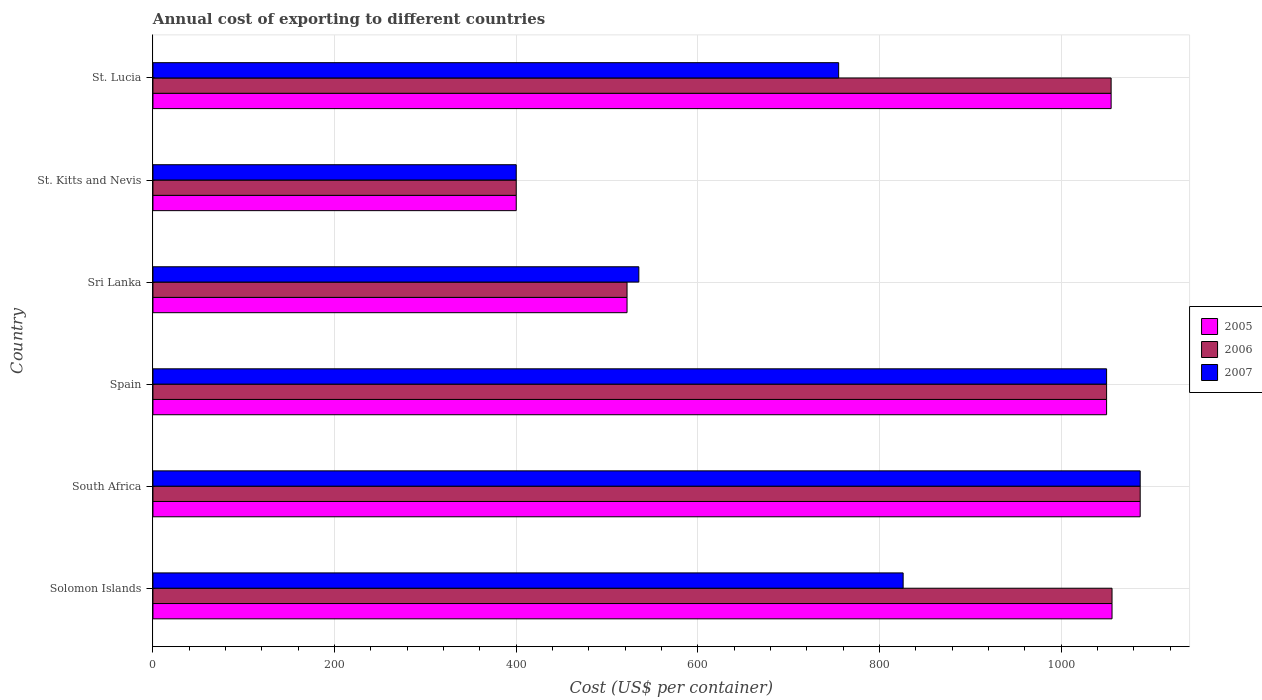How many groups of bars are there?
Your answer should be very brief. 6. Are the number of bars per tick equal to the number of legend labels?
Give a very brief answer. Yes. How many bars are there on the 4th tick from the top?
Your answer should be compact. 3. What is the label of the 5th group of bars from the top?
Make the answer very short. South Africa. What is the total annual cost of exporting in 2005 in South Africa?
Your answer should be very brief. 1087. Across all countries, what is the maximum total annual cost of exporting in 2005?
Offer a terse response. 1087. Across all countries, what is the minimum total annual cost of exporting in 2005?
Provide a short and direct response. 400. In which country was the total annual cost of exporting in 2006 maximum?
Provide a short and direct response. South Africa. In which country was the total annual cost of exporting in 2005 minimum?
Offer a terse response. St. Kitts and Nevis. What is the total total annual cost of exporting in 2005 in the graph?
Ensure brevity in your answer.  5170. What is the difference between the total annual cost of exporting in 2005 in Spain and that in Sri Lanka?
Ensure brevity in your answer.  528. What is the difference between the total annual cost of exporting in 2006 in Sri Lanka and the total annual cost of exporting in 2007 in Spain?
Give a very brief answer. -528. What is the average total annual cost of exporting in 2006 per country?
Ensure brevity in your answer.  861.67. What is the ratio of the total annual cost of exporting in 2006 in South Africa to that in St. Lucia?
Your answer should be compact. 1.03. What is the difference between the highest and the lowest total annual cost of exporting in 2006?
Provide a short and direct response. 687. How many bars are there?
Provide a short and direct response. 18. What is the difference between two consecutive major ticks on the X-axis?
Ensure brevity in your answer.  200. Are the values on the major ticks of X-axis written in scientific E-notation?
Your response must be concise. No. Does the graph contain any zero values?
Offer a very short reply. No. Does the graph contain grids?
Ensure brevity in your answer.  Yes. Where does the legend appear in the graph?
Make the answer very short. Center right. How many legend labels are there?
Provide a succinct answer. 3. What is the title of the graph?
Provide a short and direct response. Annual cost of exporting to different countries. Does "1965" appear as one of the legend labels in the graph?
Provide a short and direct response. No. What is the label or title of the X-axis?
Make the answer very short. Cost (US$ per container). What is the label or title of the Y-axis?
Keep it short and to the point. Country. What is the Cost (US$ per container) of 2005 in Solomon Islands?
Provide a short and direct response. 1056. What is the Cost (US$ per container) of 2006 in Solomon Islands?
Ensure brevity in your answer.  1056. What is the Cost (US$ per container) of 2007 in Solomon Islands?
Keep it short and to the point. 826. What is the Cost (US$ per container) in 2005 in South Africa?
Ensure brevity in your answer.  1087. What is the Cost (US$ per container) in 2006 in South Africa?
Provide a succinct answer. 1087. What is the Cost (US$ per container) of 2007 in South Africa?
Make the answer very short. 1087. What is the Cost (US$ per container) in 2005 in Spain?
Make the answer very short. 1050. What is the Cost (US$ per container) in 2006 in Spain?
Ensure brevity in your answer.  1050. What is the Cost (US$ per container) of 2007 in Spain?
Keep it short and to the point. 1050. What is the Cost (US$ per container) of 2005 in Sri Lanka?
Give a very brief answer. 522. What is the Cost (US$ per container) of 2006 in Sri Lanka?
Keep it short and to the point. 522. What is the Cost (US$ per container) of 2007 in Sri Lanka?
Your answer should be very brief. 535. What is the Cost (US$ per container) in 2006 in St. Kitts and Nevis?
Give a very brief answer. 400. What is the Cost (US$ per container) of 2005 in St. Lucia?
Provide a short and direct response. 1055. What is the Cost (US$ per container) of 2006 in St. Lucia?
Your answer should be very brief. 1055. What is the Cost (US$ per container) in 2007 in St. Lucia?
Offer a terse response. 755. Across all countries, what is the maximum Cost (US$ per container) in 2005?
Offer a terse response. 1087. Across all countries, what is the maximum Cost (US$ per container) in 2006?
Offer a terse response. 1087. Across all countries, what is the maximum Cost (US$ per container) of 2007?
Keep it short and to the point. 1087. Across all countries, what is the minimum Cost (US$ per container) in 2007?
Your response must be concise. 400. What is the total Cost (US$ per container) of 2005 in the graph?
Provide a short and direct response. 5170. What is the total Cost (US$ per container) in 2006 in the graph?
Make the answer very short. 5170. What is the total Cost (US$ per container) of 2007 in the graph?
Ensure brevity in your answer.  4653. What is the difference between the Cost (US$ per container) in 2005 in Solomon Islands and that in South Africa?
Give a very brief answer. -31. What is the difference between the Cost (US$ per container) of 2006 in Solomon Islands and that in South Africa?
Provide a succinct answer. -31. What is the difference between the Cost (US$ per container) in 2007 in Solomon Islands and that in South Africa?
Offer a very short reply. -261. What is the difference between the Cost (US$ per container) in 2005 in Solomon Islands and that in Spain?
Your answer should be compact. 6. What is the difference between the Cost (US$ per container) of 2006 in Solomon Islands and that in Spain?
Give a very brief answer. 6. What is the difference between the Cost (US$ per container) in 2007 in Solomon Islands and that in Spain?
Offer a very short reply. -224. What is the difference between the Cost (US$ per container) of 2005 in Solomon Islands and that in Sri Lanka?
Provide a succinct answer. 534. What is the difference between the Cost (US$ per container) in 2006 in Solomon Islands and that in Sri Lanka?
Make the answer very short. 534. What is the difference between the Cost (US$ per container) in 2007 in Solomon Islands and that in Sri Lanka?
Your answer should be very brief. 291. What is the difference between the Cost (US$ per container) in 2005 in Solomon Islands and that in St. Kitts and Nevis?
Provide a short and direct response. 656. What is the difference between the Cost (US$ per container) in 2006 in Solomon Islands and that in St. Kitts and Nevis?
Keep it short and to the point. 656. What is the difference between the Cost (US$ per container) of 2007 in Solomon Islands and that in St. Kitts and Nevis?
Make the answer very short. 426. What is the difference between the Cost (US$ per container) in 2006 in Solomon Islands and that in St. Lucia?
Ensure brevity in your answer.  1. What is the difference between the Cost (US$ per container) of 2005 in South Africa and that in Spain?
Your response must be concise. 37. What is the difference between the Cost (US$ per container) in 2007 in South Africa and that in Spain?
Your response must be concise. 37. What is the difference between the Cost (US$ per container) in 2005 in South Africa and that in Sri Lanka?
Keep it short and to the point. 565. What is the difference between the Cost (US$ per container) of 2006 in South Africa and that in Sri Lanka?
Keep it short and to the point. 565. What is the difference between the Cost (US$ per container) of 2007 in South Africa and that in Sri Lanka?
Your answer should be very brief. 552. What is the difference between the Cost (US$ per container) in 2005 in South Africa and that in St. Kitts and Nevis?
Your answer should be compact. 687. What is the difference between the Cost (US$ per container) of 2006 in South Africa and that in St. Kitts and Nevis?
Your answer should be compact. 687. What is the difference between the Cost (US$ per container) of 2007 in South Africa and that in St. Kitts and Nevis?
Ensure brevity in your answer.  687. What is the difference between the Cost (US$ per container) in 2005 in South Africa and that in St. Lucia?
Give a very brief answer. 32. What is the difference between the Cost (US$ per container) of 2006 in South Africa and that in St. Lucia?
Provide a short and direct response. 32. What is the difference between the Cost (US$ per container) in 2007 in South Africa and that in St. Lucia?
Offer a terse response. 332. What is the difference between the Cost (US$ per container) of 2005 in Spain and that in Sri Lanka?
Make the answer very short. 528. What is the difference between the Cost (US$ per container) of 2006 in Spain and that in Sri Lanka?
Offer a very short reply. 528. What is the difference between the Cost (US$ per container) of 2007 in Spain and that in Sri Lanka?
Keep it short and to the point. 515. What is the difference between the Cost (US$ per container) of 2005 in Spain and that in St. Kitts and Nevis?
Make the answer very short. 650. What is the difference between the Cost (US$ per container) of 2006 in Spain and that in St. Kitts and Nevis?
Ensure brevity in your answer.  650. What is the difference between the Cost (US$ per container) in 2007 in Spain and that in St. Kitts and Nevis?
Offer a very short reply. 650. What is the difference between the Cost (US$ per container) in 2005 in Spain and that in St. Lucia?
Keep it short and to the point. -5. What is the difference between the Cost (US$ per container) in 2006 in Spain and that in St. Lucia?
Provide a short and direct response. -5. What is the difference between the Cost (US$ per container) of 2007 in Spain and that in St. Lucia?
Your answer should be compact. 295. What is the difference between the Cost (US$ per container) of 2005 in Sri Lanka and that in St. Kitts and Nevis?
Your answer should be very brief. 122. What is the difference between the Cost (US$ per container) of 2006 in Sri Lanka and that in St. Kitts and Nevis?
Ensure brevity in your answer.  122. What is the difference between the Cost (US$ per container) in 2007 in Sri Lanka and that in St. Kitts and Nevis?
Your answer should be very brief. 135. What is the difference between the Cost (US$ per container) of 2005 in Sri Lanka and that in St. Lucia?
Ensure brevity in your answer.  -533. What is the difference between the Cost (US$ per container) in 2006 in Sri Lanka and that in St. Lucia?
Your answer should be very brief. -533. What is the difference between the Cost (US$ per container) of 2007 in Sri Lanka and that in St. Lucia?
Offer a terse response. -220. What is the difference between the Cost (US$ per container) of 2005 in St. Kitts and Nevis and that in St. Lucia?
Give a very brief answer. -655. What is the difference between the Cost (US$ per container) in 2006 in St. Kitts and Nevis and that in St. Lucia?
Ensure brevity in your answer.  -655. What is the difference between the Cost (US$ per container) in 2007 in St. Kitts and Nevis and that in St. Lucia?
Offer a terse response. -355. What is the difference between the Cost (US$ per container) in 2005 in Solomon Islands and the Cost (US$ per container) in 2006 in South Africa?
Provide a succinct answer. -31. What is the difference between the Cost (US$ per container) in 2005 in Solomon Islands and the Cost (US$ per container) in 2007 in South Africa?
Offer a terse response. -31. What is the difference between the Cost (US$ per container) of 2006 in Solomon Islands and the Cost (US$ per container) of 2007 in South Africa?
Make the answer very short. -31. What is the difference between the Cost (US$ per container) in 2005 in Solomon Islands and the Cost (US$ per container) in 2006 in Spain?
Give a very brief answer. 6. What is the difference between the Cost (US$ per container) of 2005 in Solomon Islands and the Cost (US$ per container) of 2006 in Sri Lanka?
Offer a terse response. 534. What is the difference between the Cost (US$ per container) in 2005 in Solomon Islands and the Cost (US$ per container) in 2007 in Sri Lanka?
Ensure brevity in your answer.  521. What is the difference between the Cost (US$ per container) of 2006 in Solomon Islands and the Cost (US$ per container) of 2007 in Sri Lanka?
Ensure brevity in your answer.  521. What is the difference between the Cost (US$ per container) in 2005 in Solomon Islands and the Cost (US$ per container) in 2006 in St. Kitts and Nevis?
Your answer should be compact. 656. What is the difference between the Cost (US$ per container) in 2005 in Solomon Islands and the Cost (US$ per container) in 2007 in St. Kitts and Nevis?
Provide a short and direct response. 656. What is the difference between the Cost (US$ per container) of 2006 in Solomon Islands and the Cost (US$ per container) of 2007 in St. Kitts and Nevis?
Your response must be concise. 656. What is the difference between the Cost (US$ per container) of 2005 in Solomon Islands and the Cost (US$ per container) of 2007 in St. Lucia?
Keep it short and to the point. 301. What is the difference between the Cost (US$ per container) of 2006 in Solomon Islands and the Cost (US$ per container) of 2007 in St. Lucia?
Keep it short and to the point. 301. What is the difference between the Cost (US$ per container) in 2005 in South Africa and the Cost (US$ per container) in 2007 in Spain?
Provide a short and direct response. 37. What is the difference between the Cost (US$ per container) in 2005 in South Africa and the Cost (US$ per container) in 2006 in Sri Lanka?
Your response must be concise. 565. What is the difference between the Cost (US$ per container) of 2005 in South Africa and the Cost (US$ per container) of 2007 in Sri Lanka?
Ensure brevity in your answer.  552. What is the difference between the Cost (US$ per container) in 2006 in South Africa and the Cost (US$ per container) in 2007 in Sri Lanka?
Your response must be concise. 552. What is the difference between the Cost (US$ per container) in 2005 in South Africa and the Cost (US$ per container) in 2006 in St. Kitts and Nevis?
Your answer should be compact. 687. What is the difference between the Cost (US$ per container) in 2005 in South Africa and the Cost (US$ per container) in 2007 in St. Kitts and Nevis?
Make the answer very short. 687. What is the difference between the Cost (US$ per container) of 2006 in South Africa and the Cost (US$ per container) of 2007 in St. Kitts and Nevis?
Keep it short and to the point. 687. What is the difference between the Cost (US$ per container) of 2005 in South Africa and the Cost (US$ per container) of 2006 in St. Lucia?
Give a very brief answer. 32. What is the difference between the Cost (US$ per container) of 2005 in South Africa and the Cost (US$ per container) of 2007 in St. Lucia?
Make the answer very short. 332. What is the difference between the Cost (US$ per container) of 2006 in South Africa and the Cost (US$ per container) of 2007 in St. Lucia?
Offer a very short reply. 332. What is the difference between the Cost (US$ per container) in 2005 in Spain and the Cost (US$ per container) in 2006 in Sri Lanka?
Your answer should be very brief. 528. What is the difference between the Cost (US$ per container) of 2005 in Spain and the Cost (US$ per container) of 2007 in Sri Lanka?
Provide a succinct answer. 515. What is the difference between the Cost (US$ per container) in 2006 in Spain and the Cost (US$ per container) in 2007 in Sri Lanka?
Your answer should be compact. 515. What is the difference between the Cost (US$ per container) in 2005 in Spain and the Cost (US$ per container) in 2006 in St. Kitts and Nevis?
Your answer should be very brief. 650. What is the difference between the Cost (US$ per container) in 2005 in Spain and the Cost (US$ per container) in 2007 in St. Kitts and Nevis?
Keep it short and to the point. 650. What is the difference between the Cost (US$ per container) of 2006 in Spain and the Cost (US$ per container) of 2007 in St. Kitts and Nevis?
Give a very brief answer. 650. What is the difference between the Cost (US$ per container) of 2005 in Spain and the Cost (US$ per container) of 2006 in St. Lucia?
Keep it short and to the point. -5. What is the difference between the Cost (US$ per container) in 2005 in Spain and the Cost (US$ per container) in 2007 in St. Lucia?
Keep it short and to the point. 295. What is the difference between the Cost (US$ per container) in 2006 in Spain and the Cost (US$ per container) in 2007 in St. Lucia?
Your answer should be compact. 295. What is the difference between the Cost (US$ per container) in 2005 in Sri Lanka and the Cost (US$ per container) in 2006 in St. Kitts and Nevis?
Your answer should be very brief. 122. What is the difference between the Cost (US$ per container) in 2005 in Sri Lanka and the Cost (US$ per container) in 2007 in St. Kitts and Nevis?
Your answer should be compact. 122. What is the difference between the Cost (US$ per container) of 2006 in Sri Lanka and the Cost (US$ per container) of 2007 in St. Kitts and Nevis?
Make the answer very short. 122. What is the difference between the Cost (US$ per container) in 2005 in Sri Lanka and the Cost (US$ per container) in 2006 in St. Lucia?
Provide a succinct answer. -533. What is the difference between the Cost (US$ per container) of 2005 in Sri Lanka and the Cost (US$ per container) of 2007 in St. Lucia?
Provide a succinct answer. -233. What is the difference between the Cost (US$ per container) in 2006 in Sri Lanka and the Cost (US$ per container) in 2007 in St. Lucia?
Offer a very short reply. -233. What is the difference between the Cost (US$ per container) of 2005 in St. Kitts and Nevis and the Cost (US$ per container) of 2006 in St. Lucia?
Ensure brevity in your answer.  -655. What is the difference between the Cost (US$ per container) of 2005 in St. Kitts and Nevis and the Cost (US$ per container) of 2007 in St. Lucia?
Your response must be concise. -355. What is the difference between the Cost (US$ per container) of 2006 in St. Kitts and Nevis and the Cost (US$ per container) of 2007 in St. Lucia?
Give a very brief answer. -355. What is the average Cost (US$ per container) in 2005 per country?
Give a very brief answer. 861.67. What is the average Cost (US$ per container) of 2006 per country?
Provide a short and direct response. 861.67. What is the average Cost (US$ per container) in 2007 per country?
Make the answer very short. 775.5. What is the difference between the Cost (US$ per container) of 2005 and Cost (US$ per container) of 2007 in Solomon Islands?
Your response must be concise. 230. What is the difference between the Cost (US$ per container) of 2006 and Cost (US$ per container) of 2007 in Solomon Islands?
Offer a very short reply. 230. What is the difference between the Cost (US$ per container) of 2005 and Cost (US$ per container) of 2006 in South Africa?
Your response must be concise. 0. What is the difference between the Cost (US$ per container) in 2005 and Cost (US$ per container) in 2007 in South Africa?
Provide a succinct answer. 0. What is the difference between the Cost (US$ per container) in 2005 and Cost (US$ per container) in 2006 in Spain?
Your answer should be compact. 0. What is the difference between the Cost (US$ per container) of 2005 and Cost (US$ per container) of 2007 in Spain?
Offer a terse response. 0. What is the difference between the Cost (US$ per container) in 2006 and Cost (US$ per container) in 2007 in Sri Lanka?
Your response must be concise. -13. What is the difference between the Cost (US$ per container) in 2005 and Cost (US$ per container) in 2006 in St. Kitts and Nevis?
Provide a short and direct response. 0. What is the difference between the Cost (US$ per container) in 2005 and Cost (US$ per container) in 2007 in St. Kitts and Nevis?
Your answer should be very brief. 0. What is the difference between the Cost (US$ per container) of 2006 and Cost (US$ per container) of 2007 in St. Kitts and Nevis?
Make the answer very short. 0. What is the difference between the Cost (US$ per container) in 2005 and Cost (US$ per container) in 2007 in St. Lucia?
Provide a short and direct response. 300. What is the difference between the Cost (US$ per container) in 2006 and Cost (US$ per container) in 2007 in St. Lucia?
Your answer should be very brief. 300. What is the ratio of the Cost (US$ per container) of 2005 in Solomon Islands to that in South Africa?
Provide a succinct answer. 0.97. What is the ratio of the Cost (US$ per container) of 2006 in Solomon Islands to that in South Africa?
Provide a short and direct response. 0.97. What is the ratio of the Cost (US$ per container) of 2007 in Solomon Islands to that in South Africa?
Provide a short and direct response. 0.76. What is the ratio of the Cost (US$ per container) of 2007 in Solomon Islands to that in Spain?
Provide a succinct answer. 0.79. What is the ratio of the Cost (US$ per container) in 2005 in Solomon Islands to that in Sri Lanka?
Make the answer very short. 2.02. What is the ratio of the Cost (US$ per container) in 2006 in Solomon Islands to that in Sri Lanka?
Ensure brevity in your answer.  2.02. What is the ratio of the Cost (US$ per container) of 2007 in Solomon Islands to that in Sri Lanka?
Your response must be concise. 1.54. What is the ratio of the Cost (US$ per container) of 2005 in Solomon Islands to that in St. Kitts and Nevis?
Ensure brevity in your answer.  2.64. What is the ratio of the Cost (US$ per container) in 2006 in Solomon Islands to that in St. Kitts and Nevis?
Your answer should be compact. 2.64. What is the ratio of the Cost (US$ per container) of 2007 in Solomon Islands to that in St. Kitts and Nevis?
Your answer should be compact. 2.06. What is the ratio of the Cost (US$ per container) in 2005 in Solomon Islands to that in St. Lucia?
Keep it short and to the point. 1. What is the ratio of the Cost (US$ per container) in 2006 in Solomon Islands to that in St. Lucia?
Keep it short and to the point. 1. What is the ratio of the Cost (US$ per container) in 2007 in Solomon Islands to that in St. Lucia?
Give a very brief answer. 1.09. What is the ratio of the Cost (US$ per container) of 2005 in South Africa to that in Spain?
Give a very brief answer. 1.04. What is the ratio of the Cost (US$ per container) in 2006 in South Africa to that in Spain?
Keep it short and to the point. 1.04. What is the ratio of the Cost (US$ per container) in 2007 in South Africa to that in Spain?
Give a very brief answer. 1.04. What is the ratio of the Cost (US$ per container) in 2005 in South Africa to that in Sri Lanka?
Provide a succinct answer. 2.08. What is the ratio of the Cost (US$ per container) of 2006 in South Africa to that in Sri Lanka?
Your answer should be very brief. 2.08. What is the ratio of the Cost (US$ per container) of 2007 in South Africa to that in Sri Lanka?
Make the answer very short. 2.03. What is the ratio of the Cost (US$ per container) of 2005 in South Africa to that in St. Kitts and Nevis?
Provide a short and direct response. 2.72. What is the ratio of the Cost (US$ per container) of 2006 in South Africa to that in St. Kitts and Nevis?
Ensure brevity in your answer.  2.72. What is the ratio of the Cost (US$ per container) in 2007 in South Africa to that in St. Kitts and Nevis?
Provide a succinct answer. 2.72. What is the ratio of the Cost (US$ per container) in 2005 in South Africa to that in St. Lucia?
Your answer should be very brief. 1.03. What is the ratio of the Cost (US$ per container) in 2006 in South Africa to that in St. Lucia?
Ensure brevity in your answer.  1.03. What is the ratio of the Cost (US$ per container) in 2007 in South Africa to that in St. Lucia?
Your response must be concise. 1.44. What is the ratio of the Cost (US$ per container) of 2005 in Spain to that in Sri Lanka?
Ensure brevity in your answer.  2.01. What is the ratio of the Cost (US$ per container) of 2006 in Spain to that in Sri Lanka?
Make the answer very short. 2.01. What is the ratio of the Cost (US$ per container) in 2007 in Spain to that in Sri Lanka?
Your answer should be compact. 1.96. What is the ratio of the Cost (US$ per container) of 2005 in Spain to that in St. Kitts and Nevis?
Provide a short and direct response. 2.62. What is the ratio of the Cost (US$ per container) of 2006 in Spain to that in St. Kitts and Nevis?
Your answer should be compact. 2.62. What is the ratio of the Cost (US$ per container) of 2007 in Spain to that in St. Kitts and Nevis?
Provide a succinct answer. 2.62. What is the ratio of the Cost (US$ per container) in 2005 in Spain to that in St. Lucia?
Your answer should be very brief. 1. What is the ratio of the Cost (US$ per container) of 2007 in Spain to that in St. Lucia?
Your answer should be compact. 1.39. What is the ratio of the Cost (US$ per container) of 2005 in Sri Lanka to that in St. Kitts and Nevis?
Offer a very short reply. 1.3. What is the ratio of the Cost (US$ per container) of 2006 in Sri Lanka to that in St. Kitts and Nevis?
Give a very brief answer. 1.3. What is the ratio of the Cost (US$ per container) in 2007 in Sri Lanka to that in St. Kitts and Nevis?
Give a very brief answer. 1.34. What is the ratio of the Cost (US$ per container) of 2005 in Sri Lanka to that in St. Lucia?
Ensure brevity in your answer.  0.49. What is the ratio of the Cost (US$ per container) of 2006 in Sri Lanka to that in St. Lucia?
Your answer should be very brief. 0.49. What is the ratio of the Cost (US$ per container) in 2007 in Sri Lanka to that in St. Lucia?
Provide a short and direct response. 0.71. What is the ratio of the Cost (US$ per container) of 2005 in St. Kitts and Nevis to that in St. Lucia?
Your answer should be very brief. 0.38. What is the ratio of the Cost (US$ per container) in 2006 in St. Kitts and Nevis to that in St. Lucia?
Ensure brevity in your answer.  0.38. What is the ratio of the Cost (US$ per container) in 2007 in St. Kitts and Nevis to that in St. Lucia?
Give a very brief answer. 0.53. What is the difference between the highest and the second highest Cost (US$ per container) in 2006?
Make the answer very short. 31. What is the difference between the highest and the lowest Cost (US$ per container) of 2005?
Your response must be concise. 687. What is the difference between the highest and the lowest Cost (US$ per container) in 2006?
Make the answer very short. 687. What is the difference between the highest and the lowest Cost (US$ per container) of 2007?
Ensure brevity in your answer.  687. 